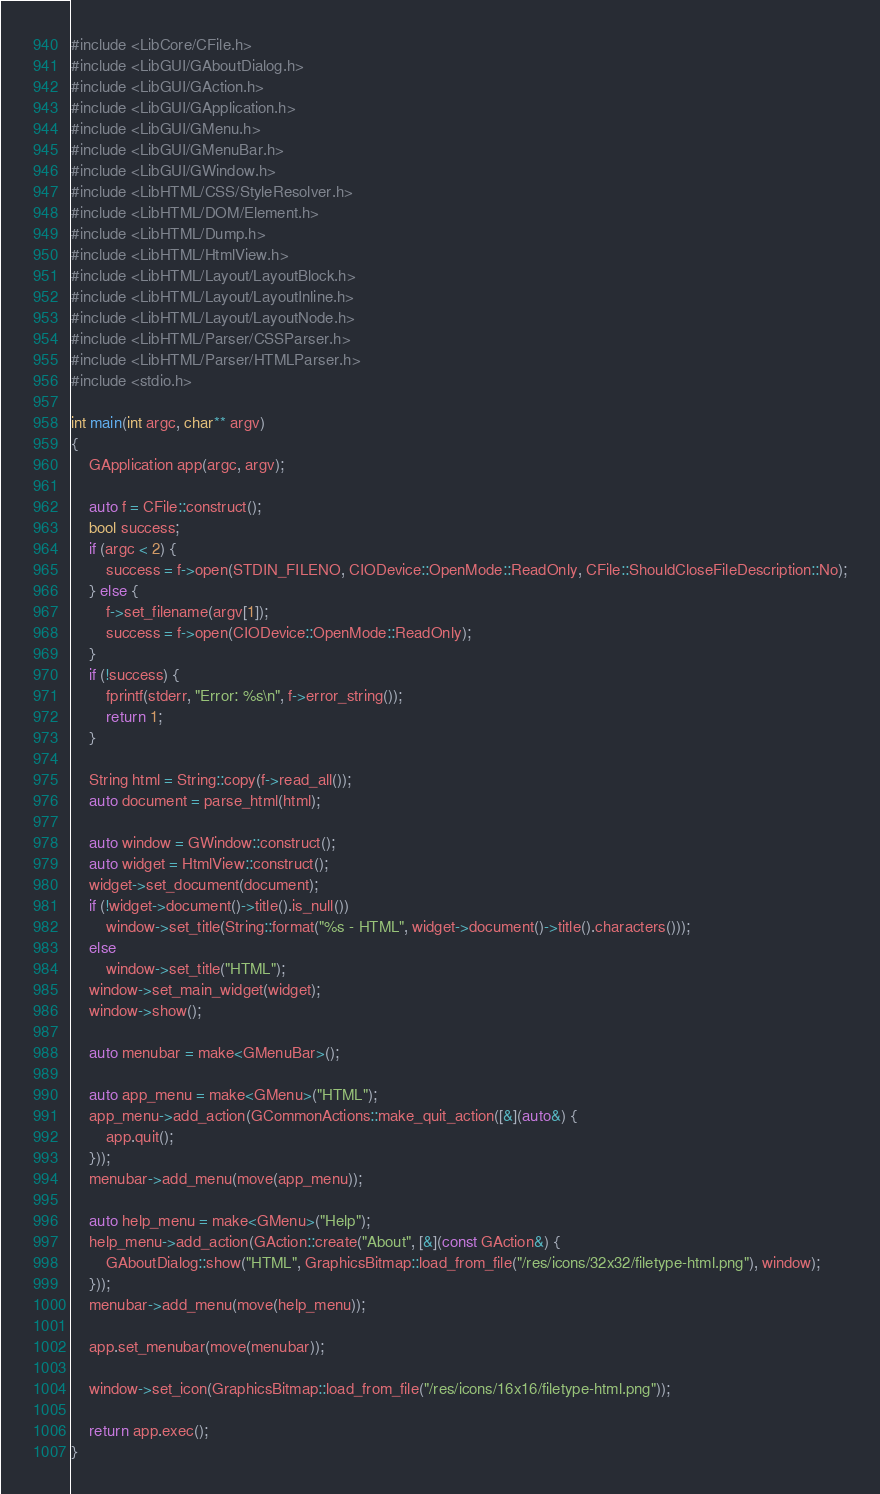<code> <loc_0><loc_0><loc_500><loc_500><_C++_>#include <LibCore/CFile.h>
#include <LibGUI/GAboutDialog.h>
#include <LibGUI/GAction.h>
#include <LibGUI/GApplication.h>
#include <LibGUI/GMenu.h>
#include <LibGUI/GMenuBar.h>
#include <LibGUI/GWindow.h>
#include <LibHTML/CSS/StyleResolver.h>
#include <LibHTML/DOM/Element.h>
#include <LibHTML/Dump.h>
#include <LibHTML/HtmlView.h>
#include <LibHTML/Layout/LayoutBlock.h>
#include <LibHTML/Layout/LayoutInline.h>
#include <LibHTML/Layout/LayoutNode.h>
#include <LibHTML/Parser/CSSParser.h>
#include <LibHTML/Parser/HTMLParser.h>
#include <stdio.h>

int main(int argc, char** argv)
{
    GApplication app(argc, argv);

    auto f = CFile::construct();
    bool success;
    if (argc < 2) {
        success = f->open(STDIN_FILENO, CIODevice::OpenMode::ReadOnly, CFile::ShouldCloseFileDescription::No);
    } else {
        f->set_filename(argv[1]);
        success = f->open(CIODevice::OpenMode::ReadOnly);
    }
    if (!success) {
        fprintf(stderr, "Error: %s\n", f->error_string());
        return 1;
    }

    String html = String::copy(f->read_all());
    auto document = parse_html(html);

    auto window = GWindow::construct();
    auto widget = HtmlView::construct();
    widget->set_document(document);
    if (!widget->document()->title().is_null())
        window->set_title(String::format("%s - HTML", widget->document()->title().characters()));
    else
        window->set_title("HTML");
    window->set_main_widget(widget);
    window->show();

    auto menubar = make<GMenuBar>();

    auto app_menu = make<GMenu>("HTML");
    app_menu->add_action(GCommonActions::make_quit_action([&](auto&) {
        app.quit();
    }));
    menubar->add_menu(move(app_menu));

    auto help_menu = make<GMenu>("Help");
    help_menu->add_action(GAction::create("About", [&](const GAction&) {
        GAboutDialog::show("HTML", GraphicsBitmap::load_from_file("/res/icons/32x32/filetype-html.png"), window);
    }));
    menubar->add_menu(move(help_menu));

    app.set_menubar(move(menubar));

    window->set_icon(GraphicsBitmap::load_from_file("/res/icons/16x16/filetype-html.png"));

    return app.exec();
}
</code> 